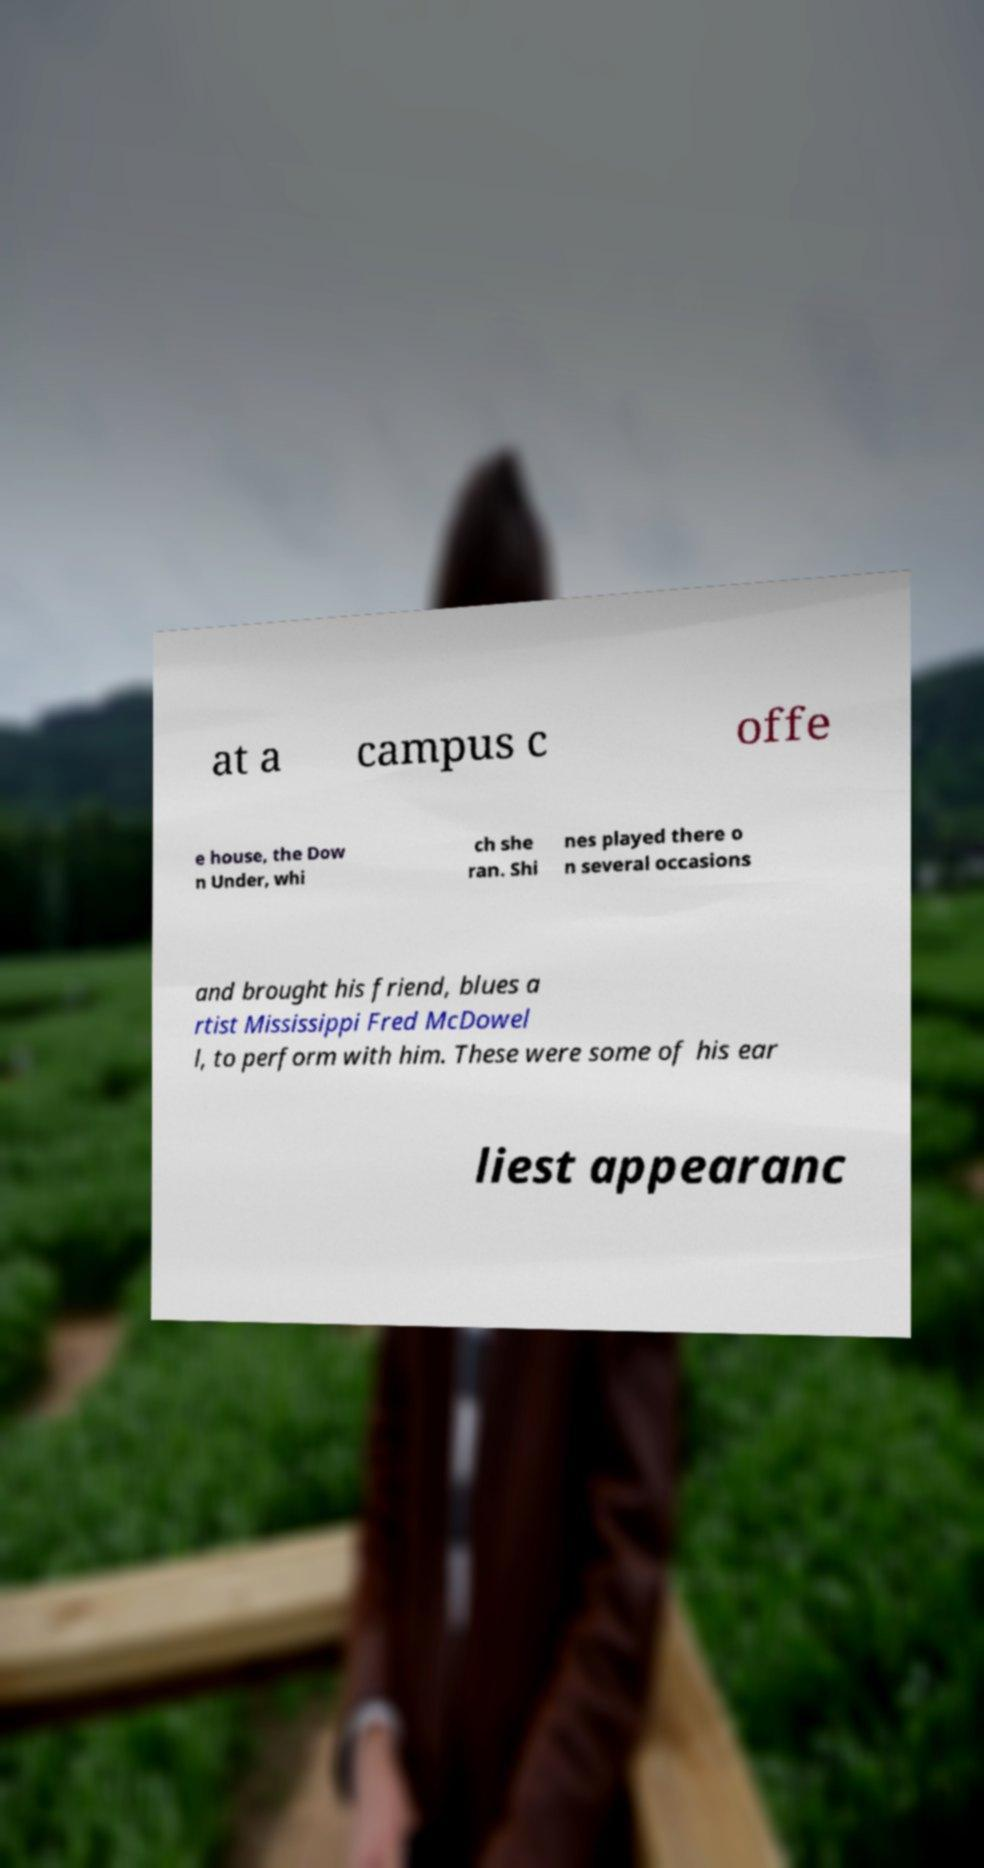Can you read and provide the text displayed in the image?This photo seems to have some interesting text. Can you extract and type it out for me? at a campus c offe e house, the Dow n Under, whi ch she ran. Shi nes played there o n several occasions and brought his friend, blues a rtist Mississippi Fred McDowel l, to perform with him. These were some of his ear liest appearanc 